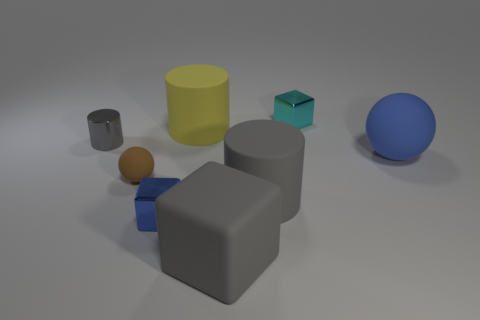Do the small cyan thing and the blue object behind the small brown thing have the same shape?
Ensure brevity in your answer.  No. There is a metal thing that is both behind the blue ball and in front of the cyan metallic block; what is its size?
Offer a very short reply. Small. How many large gray rubber things are there?
Offer a very short reply. 2. What material is the blue thing that is the same size as the cyan metallic block?
Your answer should be very brief. Metal. Are there any gray matte cubes of the same size as the yellow object?
Your answer should be compact. Yes. Do the rubber thing right of the big gray rubber cylinder and the small metallic object that is in front of the small gray object have the same color?
Make the answer very short. Yes. How many rubber objects are small brown spheres or big objects?
Keep it short and to the point. 5. There is a metal object that is to the left of the metallic block that is on the left side of the gray rubber cube; what number of big balls are on the left side of it?
Your answer should be very brief. 0. The blue object that is the same material as the brown sphere is what size?
Make the answer very short. Large. How many tiny metal blocks are the same color as the big rubber ball?
Your answer should be compact. 1. 